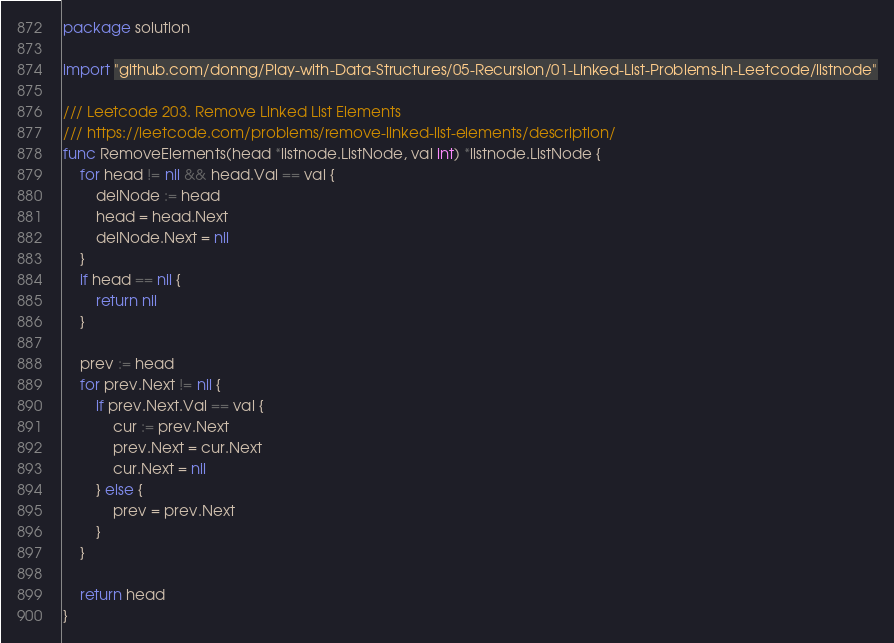Convert code to text. <code><loc_0><loc_0><loc_500><loc_500><_Go_>package solution

import "github.com/donng/Play-with-Data-Structures/05-Recursion/01-Linked-List-Problems-in-Leetcode/listnode"

/// Leetcode 203. Remove Linked List Elements
/// https://leetcode.com/problems/remove-linked-list-elements/description/
func RemoveElements(head *listnode.ListNode, val int) *listnode.ListNode {
	for head != nil && head.Val == val {
		delNode := head
		head = head.Next
		delNode.Next = nil
	}
	if head == nil {
		return nil
	}

	prev := head
	for prev.Next != nil {
		if prev.Next.Val == val {
			cur := prev.Next
			prev.Next = cur.Next
			cur.Next = nil
		} else {
			prev = prev.Next
		}
	}

	return head
}
</code> 